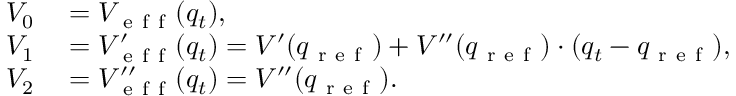Convert formula to latex. <formula><loc_0><loc_0><loc_500><loc_500>\begin{array} { r l } { V _ { 0 } } & = V _ { e f f } ( q _ { t } ) , } \\ { V _ { 1 } } & = V _ { e f f } ^ { \prime } ( q _ { t } ) = V ^ { \prime } ( q _ { r e f } ) + V ^ { \prime \prime } ( q _ { r e f } ) \cdot ( q _ { t } - q _ { r e f } ) , } \\ { V _ { 2 } } & = V _ { e f f } ^ { \prime \prime } ( q _ { t } ) = V ^ { \prime \prime } ( q _ { r e f } ) . } \end{array}</formula> 